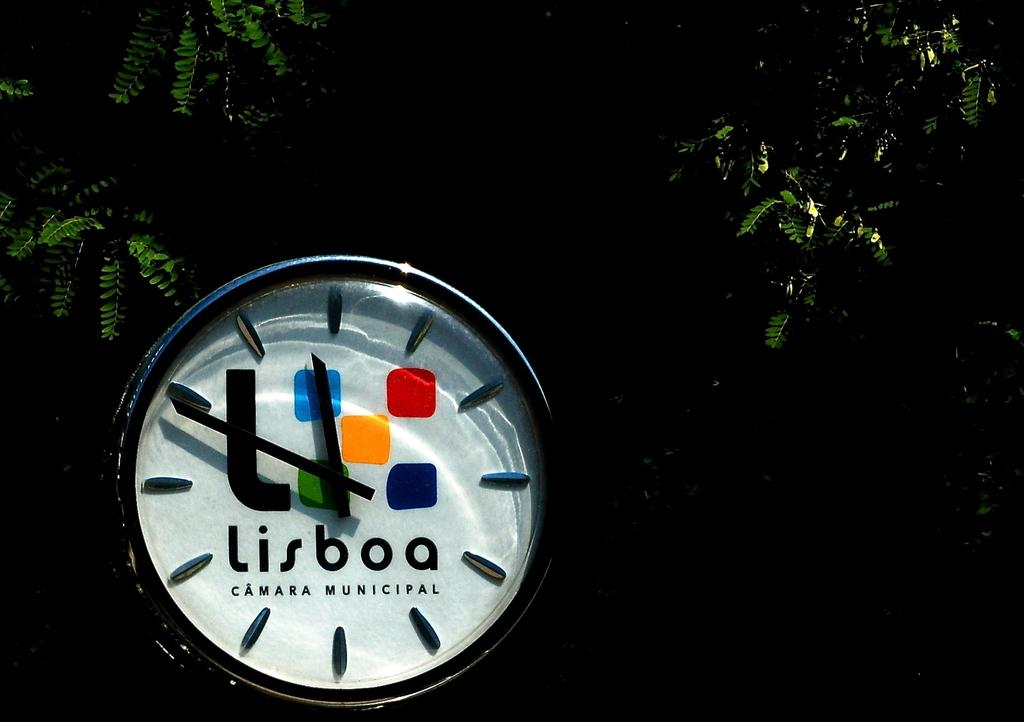Provide a one-sentence caption for the provided image. A colorful watch face displays Lisboa in black lettering. 